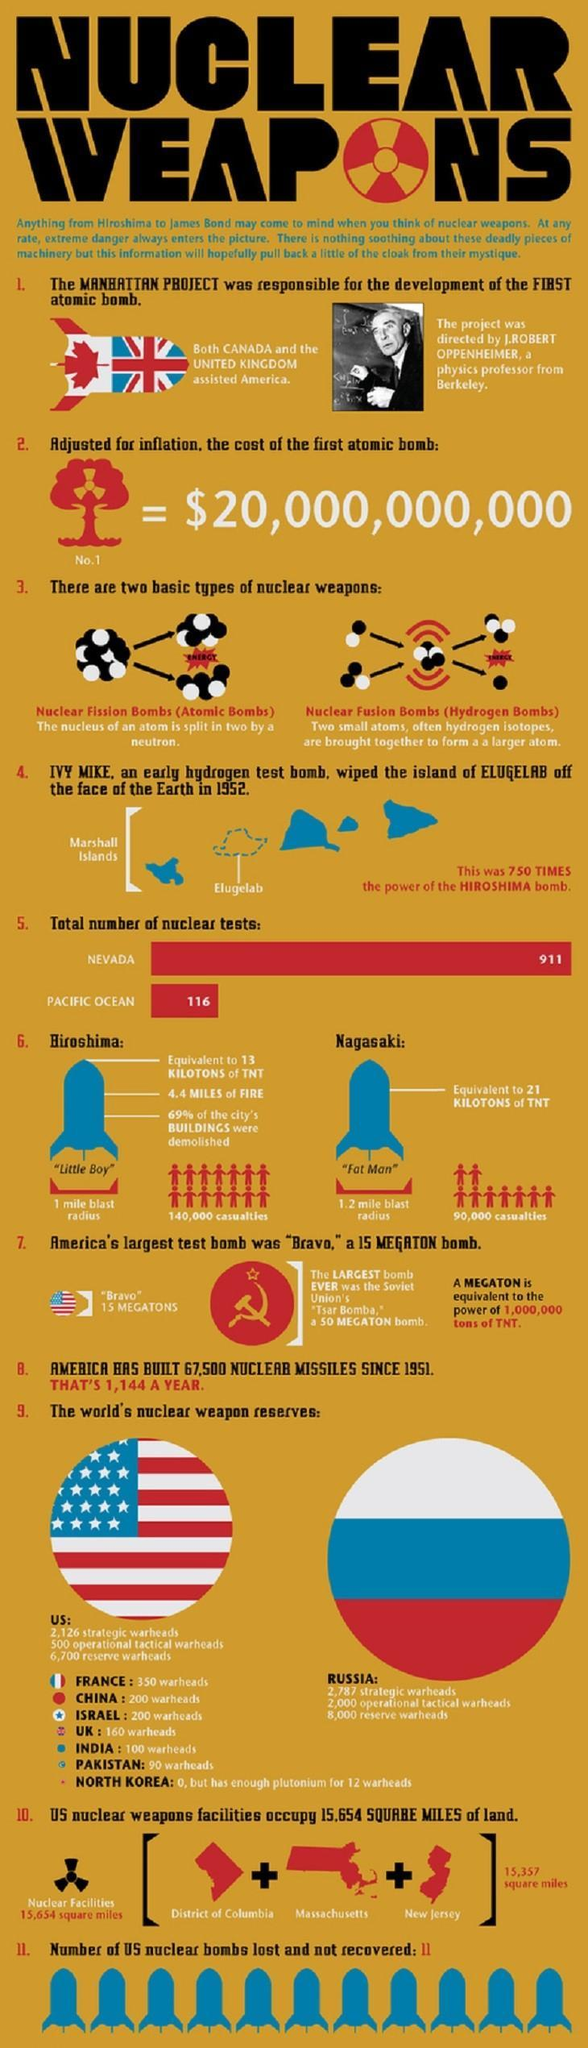Who was in charge of the Manhattan Project?
Answer the question with a short phrase. J.ROBERT OPPENHEIMER Which country has the second-largest number of nuclear weapon reserves in the world? US What is the total number of nuclear tests carried out at Nevada & pacific ocean test sites? 1027 Which country has the largest number of nuclear weapon reserves in the world? RUSSIA How many people were killed by the Hiroshima bomb blast? 140,000 Which is the most powerful nuclear bomb in history? "Tsar Bomba," Which country has the third-largest number of warheads in the world? FRANCE What is the blast radius of Nagasaki bomb? 1.2 mile What is the code name of the atomic bomb dropped on Hiroshima? "Little Boy" What is the code name of the atomic bomb dropped on Nagasaki? "Fat Man" 